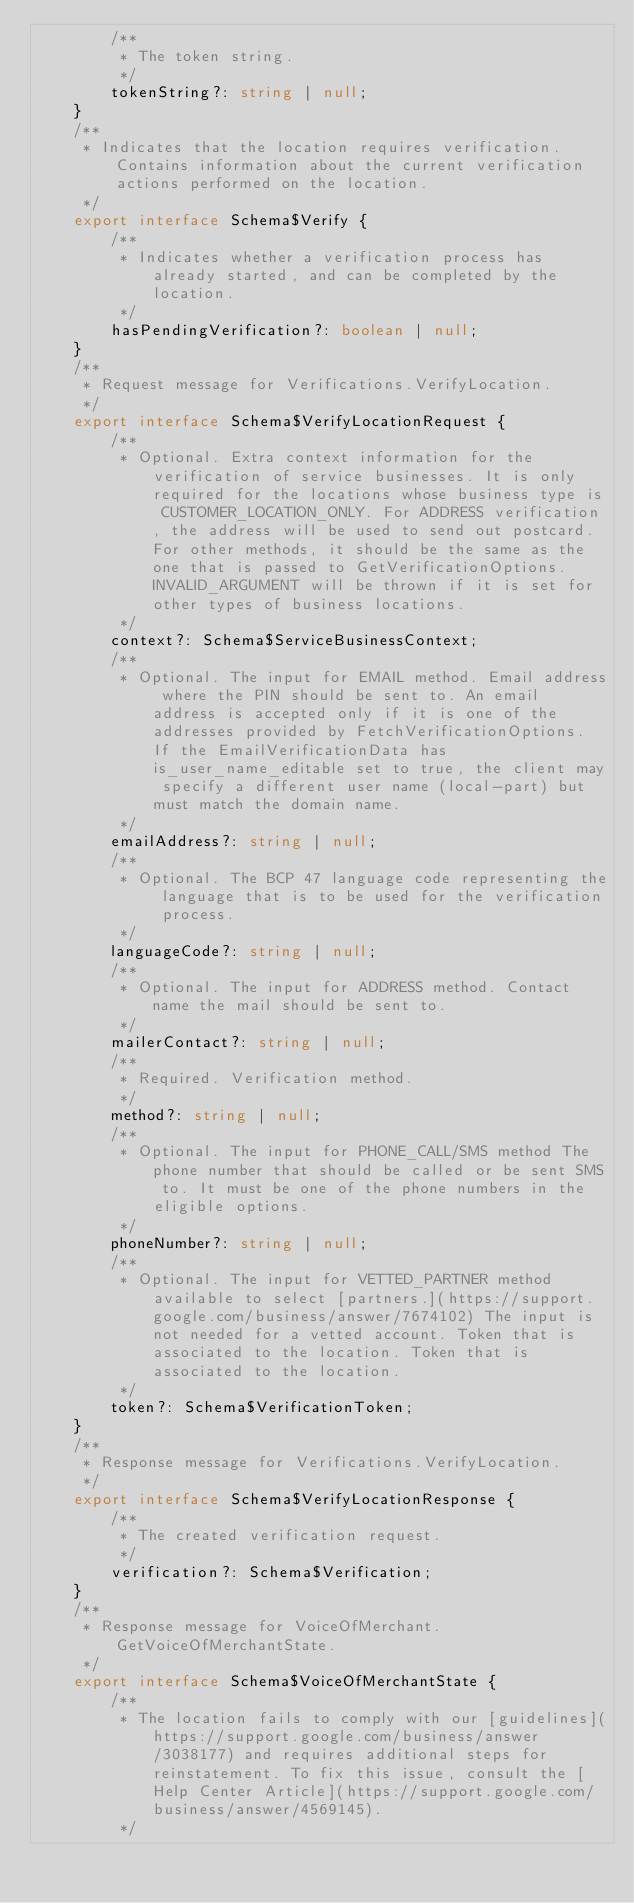Convert code to text. <code><loc_0><loc_0><loc_500><loc_500><_TypeScript_>        /**
         * The token string.
         */
        tokenString?: string | null;
    }
    /**
     * Indicates that the location requires verification. Contains information about the current verification actions performed on the location.
     */
    export interface Schema$Verify {
        /**
         * Indicates whether a verification process has already started, and can be completed by the location.
         */
        hasPendingVerification?: boolean | null;
    }
    /**
     * Request message for Verifications.VerifyLocation.
     */
    export interface Schema$VerifyLocationRequest {
        /**
         * Optional. Extra context information for the verification of service businesses. It is only required for the locations whose business type is CUSTOMER_LOCATION_ONLY. For ADDRESS verification, the address will be used to send out postcard. For other methods, it should be the same as the one that is passed to GetVerificationOptions. INVALID_ARGUMENT will be thrown if it is set for other types of business locations.
         */
        context?: Schema$ServiceBusinessContext;
        /**
         * Optional. The input for EMAIL method. Email address where the PIN should be sent to. An email address is accepted only if it is one of the addresses provided by FetchVerificationOptions. If the EmailVerificationData has is_user_name_editable set to true, the client may specify a different user name (local-part) but must match the domain name.
         */
        emailAddress?: string | null;
        /**
         * Optional. The BCP 47 language code representing the language that is to be used for the verification process.
         */
        languageCode?: string | null;
        /**
         * Optional. The input for ADDRESS method. Contact name the mail should be sent to.
         */
        mailerContact?: string | null;
        /**
         * Required. Verification method.
         */
        method?: string | null;
        /**
         * Optional. The input for PHONE_CALL/SMS method The phone number that should be called or be sent SMS to. It must be one of the phone numbers in the eligible options.
         */
        phoneNumber?: string | null;
        /**
         * Optional. The input for VETTED_PARTNER method available to select [partners.](https://support.google.com/business/answer/7674102) The input is not needed for a vetted account. Token that is associated to the location. Token that is associated to the location.
         */
        token?: Schema$VerificationToken;
    }
    /**
     * Response message for Verifications.VerifyLocation.
     */
    export interface Schema$VerifyLocationResponse {
        /**
         * The created verification request.
         */
        verification?: Schema$Verification;
    }
    /**
     * Response message for VoiceOfMerchant.GetVoiceOfMerchantState.
     */
    export interface Schema$VoiceOfMerchantState {
        /**
         * The location fails to comply with our [guidelines](https://support.google.com/business/answer/3038177) and requires additional steps for reinstatement. To fix this issue, consult the [Help Center Article](https://support.google.com/business/answer/4569145).
         */</code> 